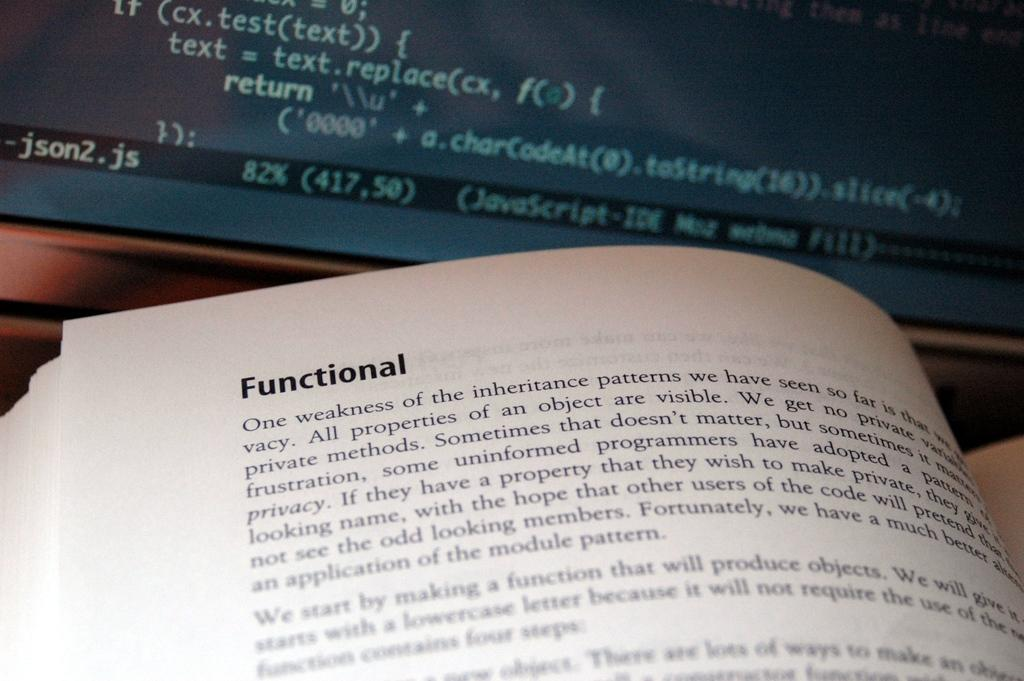What object is present in the image that is typically used for reading? There is a book in the image that is typically used for reading. What is the state of the book in the image? The book is opened in the image. What can be seen on the pages of the book? There is text visible on the book. What other object with text is present in the image? There is a screen in the image with text visible on it. What type of drink is being served in the image? There is no drink present in the image; it features a book and a screen with text. 